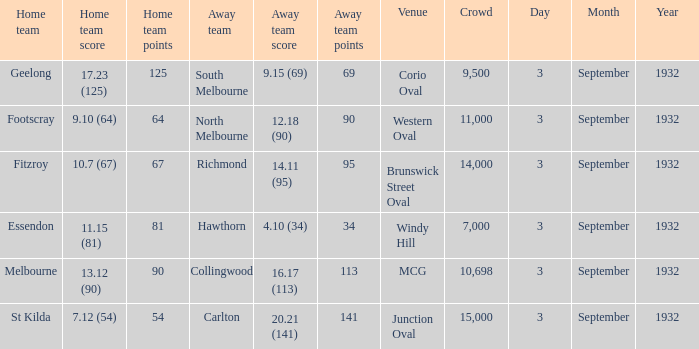What is the name of the Venue for the team that has an Away team score of 14.11 (95)? Brunswick Street Oval. 